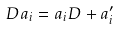<formula> <loc_0><loc_0><loc_500><loc_500>D a _ { i } = a _ { i } D + a _ { i } ^ { \prime }</formula> 